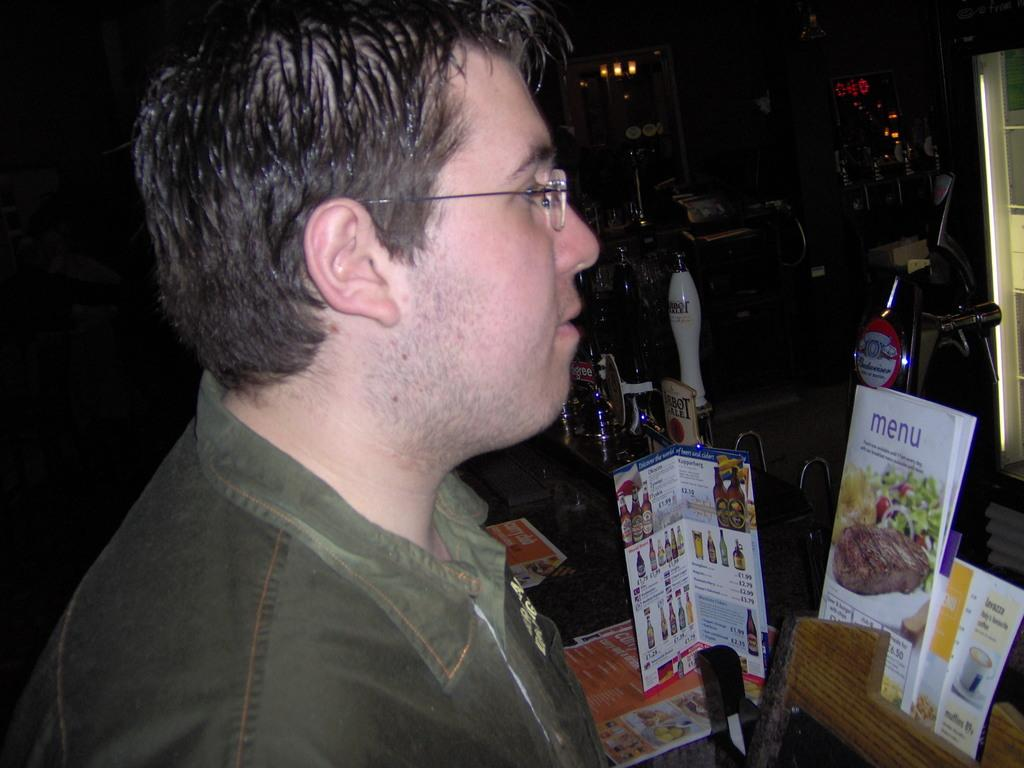What is the main subject in the image? There is a person standing in the image. What is located behind the person? There is a table behind the person. What items can be seen on the table? The table contains bottles, papers, books, and a stand. What can be seen on the backside of the image? There are lights and a wall visible on the backside of the image. What type of goat is sitting on the table in the image? There is no goat present in the image; the table contains bottles, papers, books, and a stand. What is the size of the person in the image? The size of the person cannot be determined from the image alone, as there is no reference point for comparison. 